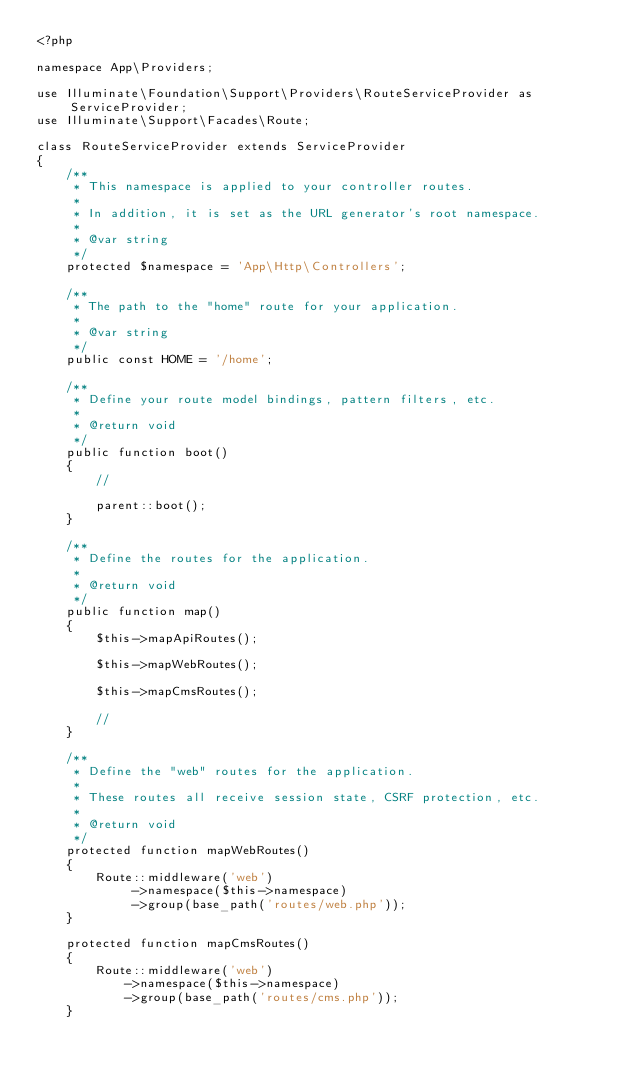<code> <loc_0><loc_0><loc_500><loc_500><_PHP_><?php

namespace App\Providers;

use Illuminate\Foundation\Support\Providers\RouteServiceProvider as ServiceProvider;
use Illuminate\Support\Facades\Route;

class RouteServiceProvider extends ServiceProvider
{
    /**
     * This namespace is applied to your controller routes.
     *
     * In addition, it is set as the URL generator's root namespace.
     *
     * @var string
     */
    protected $namespace = 'App\Http\Controllers';

    /**
     * The path to the "home" route for your application.
     *
     * @var string
     */
    public const HOME = '/home';

    /**
     * Define your route model bindings, pattern filters, etc.
     *
     * @return void
     */
    public function boot()
    {
        //

        parent::boot();
    }

    /**
     * Define the routes for the application.
     *
     * @return void
     */
    public function map()
    {
        $this->mapApiRoutes();

        $this->mapWebRoutes();

        $this->mapCmsRoutes();

        //
    }

    /**
     * Define the "web" routes for the application.
     *
     * These routes all receive session state, CSRF protection, etc.
     *
     * @return void
     */
    protected function mapWebRoutes()
    {
        Route::middleware('web')
             ->namespace($this->namespace)
             ->group(base_path('routes/web.php'));
    }

    protected function mapCmsRoutes()
    {
        Route::middleware('web')
            ->namespace($this->namespace)
            ->group(base_path('routes/cms.php'));
    }
</code> 